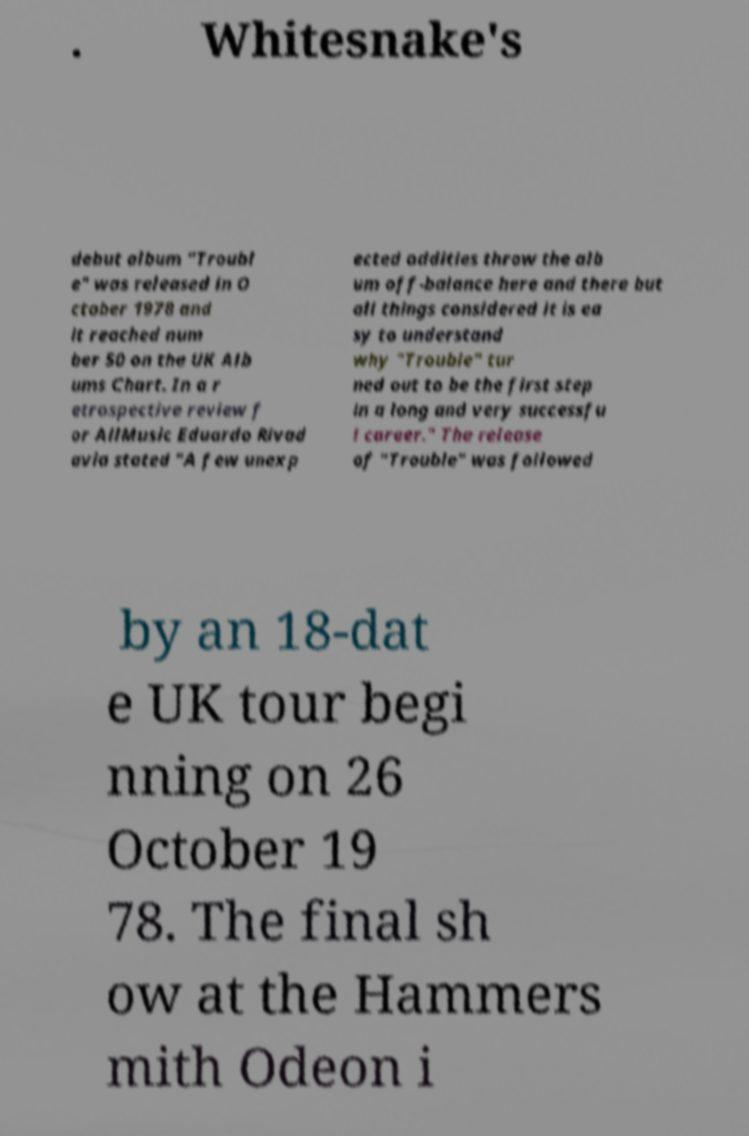Please read and relay the text visible in this image. What does it say? . Whitesnake's debut album "Troubl e" was released in O ctober 1978 and it reached num ber 50 on the UK Alb ums Chart. In a r etrospective review f or AllMusic Eduardo Rivad avia stated "A few unexp ected oddities throw the alb um off-balance here and there but all things considered it is ea sy to understand why "Trouble" tur ned out to be the first step in a long and very successfu l career." The release of "Trouble" was followed by an 18-dat e UK tour begi nning on 26 October 19 78. The final sh ow at the Hammers mith Odeon i 